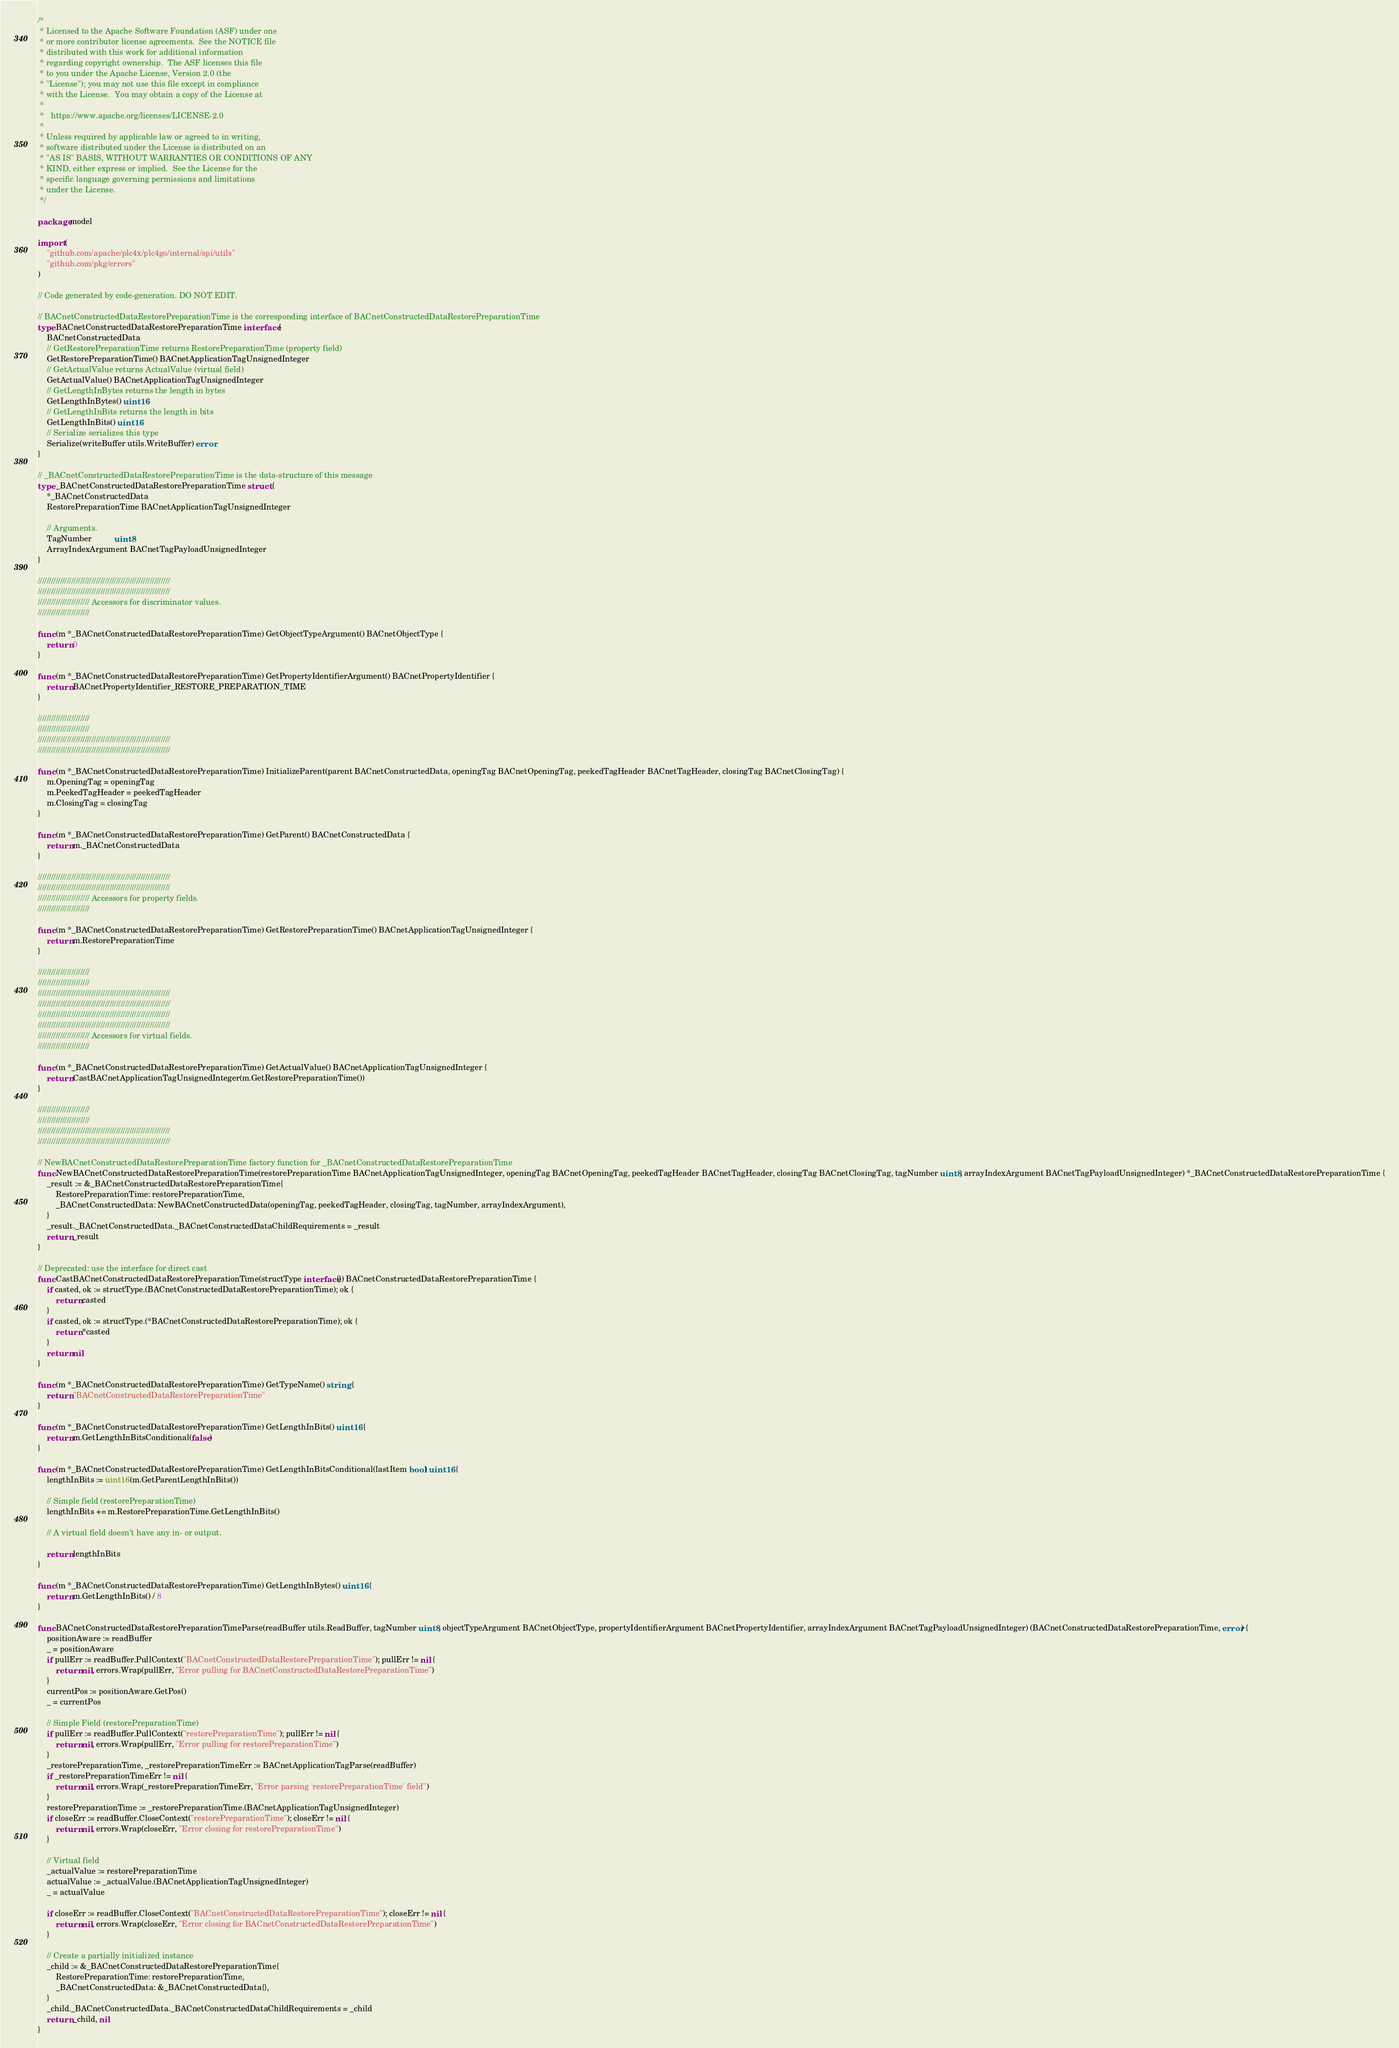Convert code to text. <code><loc_0><loc_0><loc_500><loc_500><_Go_>/*
 * Licensed to the Apache Software Foundation (ASF) under one
 * or more contributor license agreements.  See the NOTICE file
 * distributed with this work for additional information
 * regarding copyright ownership.  The ASF licenses this file
 * to you under the Apache License, Version 2.0 (the
 * "License"); you may not use this file except in compliance
 * with the License.  You may obtain a copy of the License at
 *
 *   https://www.apache.org/licenses/LICENSE-2.0
 *
 * Unless required by applicable law or agreed to in writing,
 * software distributed under the License is distributed on an
 * "AS IS" BASIS, WITHOUT WARRANTIES OR CONDITIONS OF ANY
 * KIND, either express or implied.  See the License for the
 * specific language governing permissions and limitations
 * under the License.
 */

package model

import (
	"github.com/apache/plc4x/plc4go/internal/spi/utils"
	"github.com/pkg/errors"
)

// Code generated by code-generation. DO NOT EDIT.

// BACnetConstructedDataRestorePreparationTime is the corresponding interface of BACnetConstructedDataRestorePreparationTime
type BACnetConstructedDataRestorePreparationTime interface {
	BACnetConstructedData
	// GetRestorePreparationTime returns RestorePreparationTime (property field)
	GetRestorePreparationTime() BACnetApplicationTagUnsignedInteger
	// GetActualValue returns ActualValue (virtual field)
	GetActualValue() BACnetApplicationTagUnsignedInteger
	// GetLengthInBytes returns the length in bytes
	GetLengthInBytes() uint16
	// GetLengthInBits returns the length in bits
	GetLengthInBits() uint16
	// Serialize serializes this type
	Serialize(writeBuffer utils.WriteBuffer) error
}

// _BACnetConstructedDataRestorePreparationTime is the data-structure of this message
type _BACnetConstructedDataRestorePreparationTime struct {
	*_BACnetConstructedData
	RestorePreparationTime BACnetApplicationTagUnsignedInteger

	// Arguments.
	TagNumber          uint8
	ArrayIndexArgument BACnetTagPayloadUnsignedInteger
}

///////////////////////////////////////////////////////////
///////////////////////////////////////////////////////////
/////////////////////// Accessors for discriminator values.
///////////////////////

func (m *_BACnetConstructedDataRestorePreparationTime) GetObjectTypeArgument() BACnetObjectType {
	return 0
}

func (m *_BACnetConstructedDataRestorePreparationTime) GetPropertyIdentifierArgument() BACnetPropertyIdentifier {
	return BACnetPropertyIdentifier_RESTORE_PREPARATION_TIME
}

///////////////////////
///////////////////////
///////////////////////////////////////////////////////////
///////////////////////////////////////////////////////////

func (m *_BACnetConstructedDataRestorePreparationTime) InitializeParent(parent BACnetConstructedData, openingTag BACnetOpeningTag, peekedTagHeader BACnetTagHeader, closingTag BACnetClosingTag) {
	m.OpeningTag = openingTag
	m.PeekedTagHeader = peekedTagHeader
	m.ClosingTag = closingTag
}

func (m *_BACnetConstructedDataRestorePreparationTime) GetParent() BACnetConstructedData {
	return m._BACnetConstructedData
}

///////////////////////////////////////////////////////////
///////////////////////////////////////////////////////////
/////////////////////// Accessors for property fields.
///////////////////////

func (m *_BACnetConstructedDataRestorePreparationTime) GetRestorePreparationTime() BACnetApplicationTagUnsignedInteger {
	return m.RestorePreparationTime
}

///////////////////////
///////////////////////
///////////////////////////////////////////////////////////
///////////////////////////////////////////////////////////
///////////////////////////////////////////////////////////
///////////////////////////////////////////////////////////
/////////////////////// Accessors for virtual fields.
///////////////////////

func (m *_BACnetConstructedDataRestorePreparationTime) GetActualValue() BACnetApplicationTagUnsignedInteger {
	return CastBACnetApplicationTagUnsignedInteger(m.GetRestorePreparationTime())
}

///////////////////////
///////////////////////
///////////////////////////////////////////////////////////
///////////////////////////////////////////////////////////

// NewBACnetConstructedDataRestorePreparationTime factory function for _BACnetConstructedDataRestorePreparationTime
func NewBACnetConstructedDataRestorePreparationTime(restorePreparationTime BACnetApplicationTagUnsignedInteger, openingTag BACnetOpeningTag, peekedTagHeader BACnetTagHeader, closingTag BACnetClosingTag, tagNumber uint8, arrayIndexArgument BACnetTagPayloadUnsignedInteger) *_BACnetConstructedDataRestorePreparationTime {
	_result := &_BACnetConstructedDataRestorePreparationTime{
		RestorePreparationTime: restorePreparationTime,
		_BACnetConstructedData: NewBACnetConstructedData(openingTag, peekedTagHeader, closingTag, tagNumber, arrayIndexArgument),
	}
	_result._BACnetConstructedData._BACnetConstructedDataChildRequirements = _result
	return _result
}

// Deprecated: use the interface for direct cast
func CastBACnetConstructedDataRestorePreparationTime(structType interface{}) BACnetConstructedDataRestorePreparationTime {
	if casted, ok := structType.(BACnetConstructedDataRestorePreparationTime); ok {
		return casted
	}
	if casted, ok := structType.(*BACnetConstructedDataRestorePreparationTime); ok {
		return *casted
	}
	return nil
}

func (m *_BACnetConstructedDataRestorePreparationTime) GetTypeName() string {
	return "BACnetConstructedDataRestorePreparationTime"
}

func (m *_BACnetConstructedDataRestorePreparationTime) GetLengthInBits() uint16 {
	return m.GetLengthInBitsConditional(false)
}

func (m *_BACnetConstructedDataRestorePreparationTime) GetLengthInBitsConditional(lastItem bool) uint16 {
	lengthInBits := uint16(m.GetParentLengthInBits())

	// Simple field (restorePreparationTime)
	lengthInBits += m.RestorePreparationTime.GetLengthInBits()

	// A virtual field doesn't have any in- or output.

	return lengthInBits
}

func (m *_BACnetConstructedDataRestorePreparationTime) GetLengthInBytes() uint16 {
	return m.GetLengthInBits() / 8
}

func BACnetConstructedDataRestorePreparationTimeParse(readBuffer utils.ReadBuffer, tagNumber uint8, objectTypeArgument BACnetObjectType, propertyIdentifierArgument BACnetPropertyIdentifier, arrayIndexArgument BACnetTagPayloadUnsignedInteger) (BACnetConstructedDataRestorePreparationTime, error) {
	positionAware := readBuffer
	_ = positionAware
	if pullErr := readBuffer.PullContext("BACnetConstructedDataRestorePreparationTime"); pullErr != nil {
		return nil, errors.Wrap(pullErr, "Error pulling for BACnetConstructedDataRestorePreparationTime")
	}
	currentPos := positionAware.GetPos()
	_ = currentPos

	// Simple Field (restorePreparationTime)
	if pullErr := readBuffer.PullContext("restorePreparationTime"); pullErr != nil {
		return nil, errors.Wrap(pullErr, "Error pulling for restorePreparationTime")
	}
	_restorePreparationTime, _restorePreparationTimeErr := BACnetApplicationTagParse(readBuffer)
	if _restorePreparationTimeErr != nil {
		return nil, errors.Wrap(_restorePreparationTimeErr, "Error parsing 'restorePreparationTime' field")
	}
	restorePreparationTime := _restorePreparationTime.(BACnetApplicationTagUnsignedInteger)
	if closeErr := readBuffer.CloseContext("restorePreparationTime"); closeErr != nil {
		return nil, errors.Wrap(closeErr, "Error closing for restorePreparationTime")
	}

	// Virtual field
	_actualValue := restorePreparationTime
	actualValue := _actualValue.(BACnetApplicationTagUnsignedInteger)
	_ = actualValue

	if closeErr := readBuffer.CloseContext("BACnetConstructedDataRestorePreparationTime"); closeErr != nil {
		return nil, errors.Wrap(closeErr, "Error closing for BACnetConstructedDataRestorePreparationTime")
	}

	// Create a partially initialized instance
	_child := &_BACnetConstructedDataRestorePreparationTime{
		RestorePreparationTime: restorePreparationTime,
		_BACnetConstructedData: &_BACnetConstructedData{},
	}
	_child._BACnetConstructedData._BACnetConstructedDataChildRequirements = _child
	return _child, nil
}
</code> 